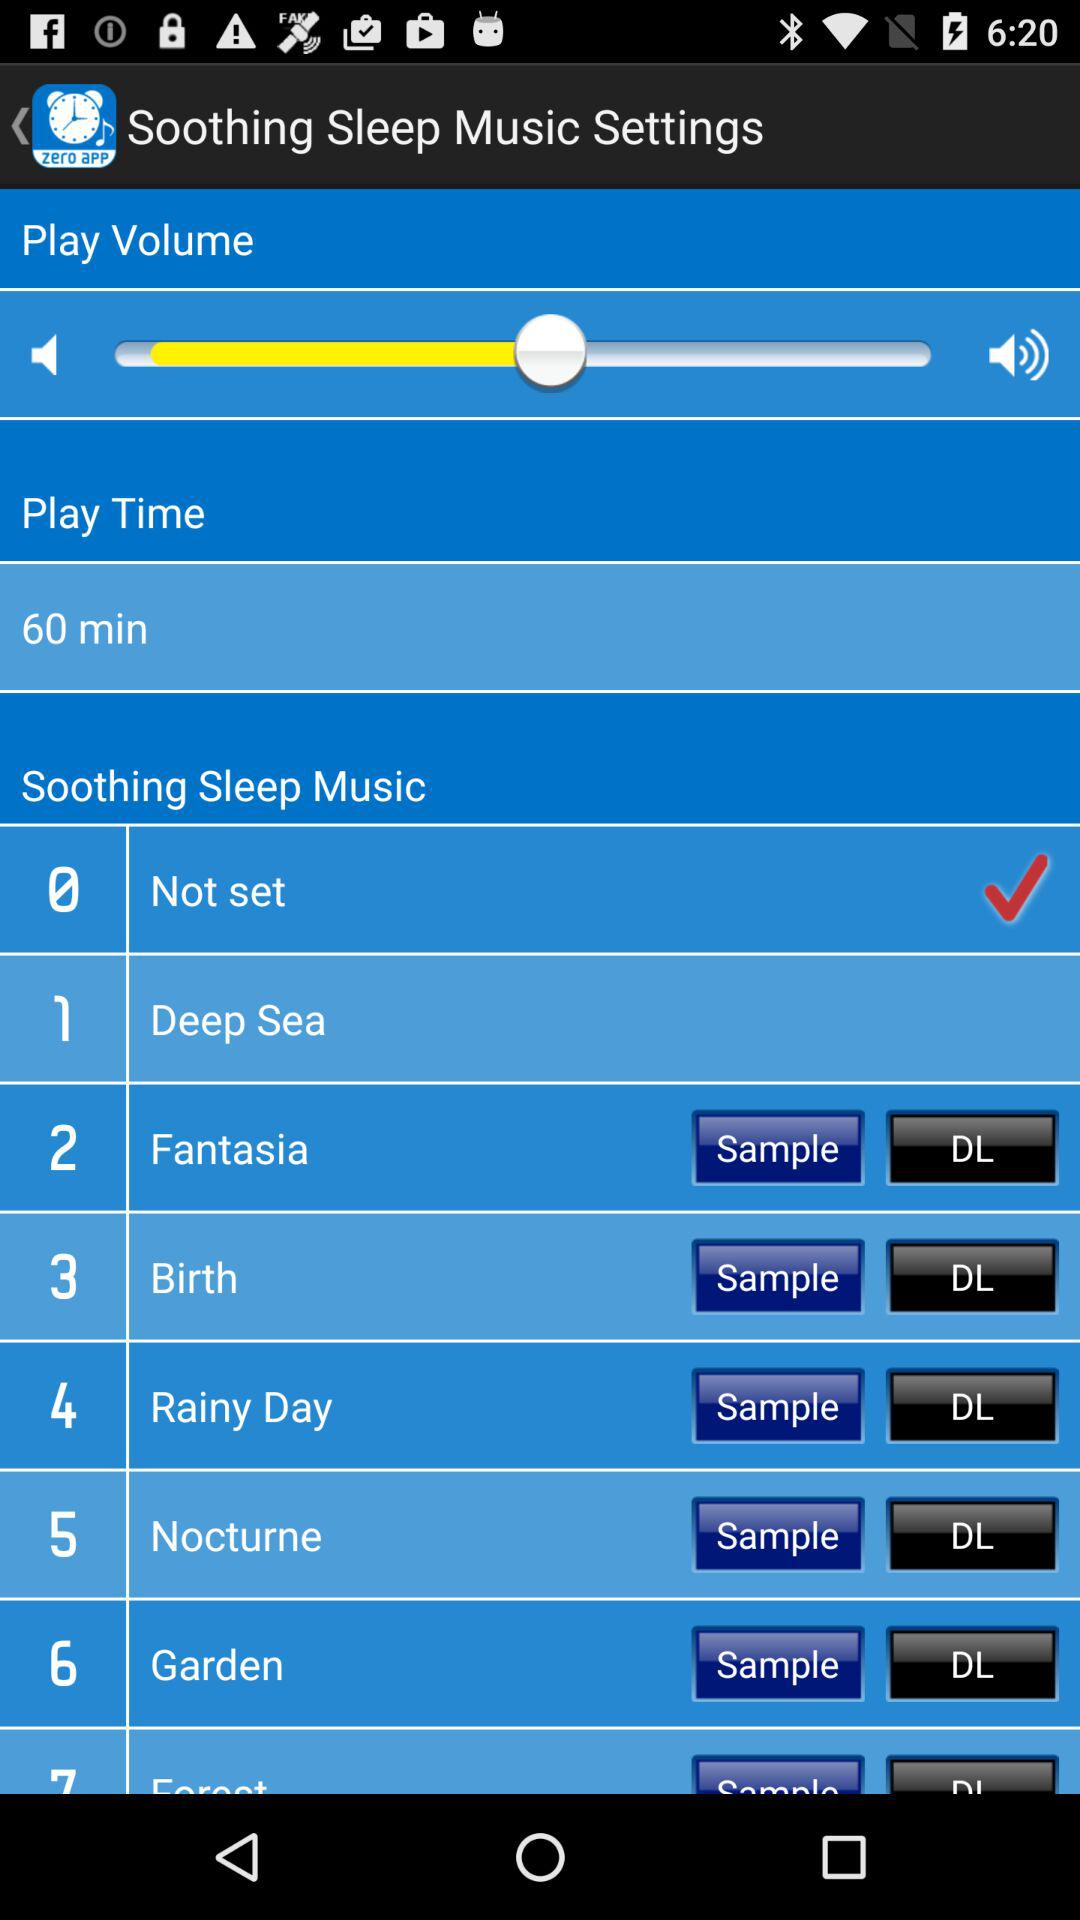What option is checked? The option checked is "Not set". 